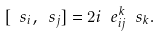<formula> <loc_0><loc_0><loc_500><loc_500>[ \ s _ { i } , \ s _ { j } ] = 2 i \ e ^ { k } _ { i j } \ s _ { k } .</formula> 